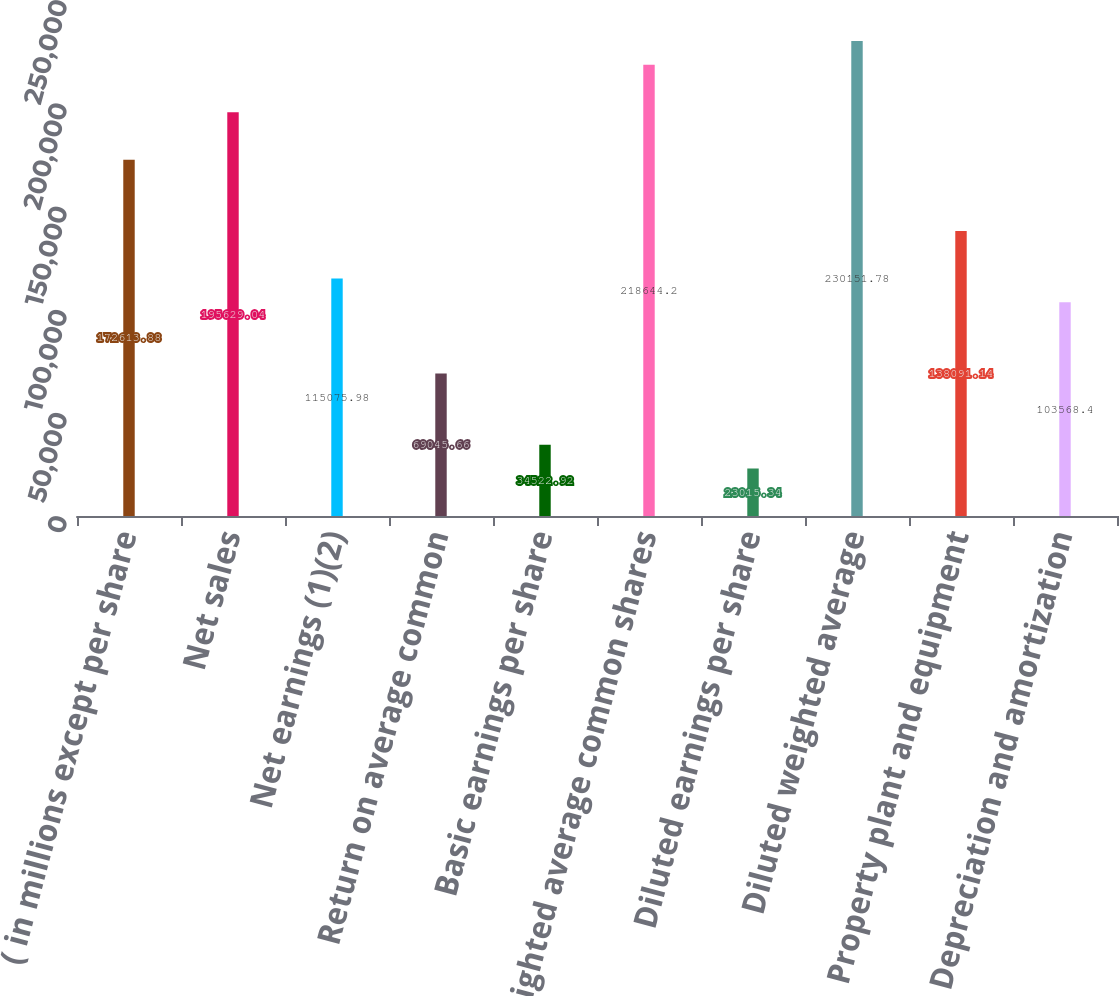Convert chart to OTSL. <chart><loc_0><loc_0><loc_500><loc_500><bar_chart><fcel>( in millions except per share<fcel>Net sales<fcel>Net earnings (1)(2)<fcel>Return on average common<fcel>Basic earnings per share<fcel>Weighted average common shares<fcel>Diluted earnings per share<fcel>Diluted weighted average<fcel>Property plant and equipment<fcel>Depreciation and amortization<nl><fcel>172614<fcel>195629<fcel>115076<fcel>69045.7<fcel>34522.9<fcel>218644<fcel>23015.3<fcel>230152<fcel>138091<fcel>103568<nl></chart> 